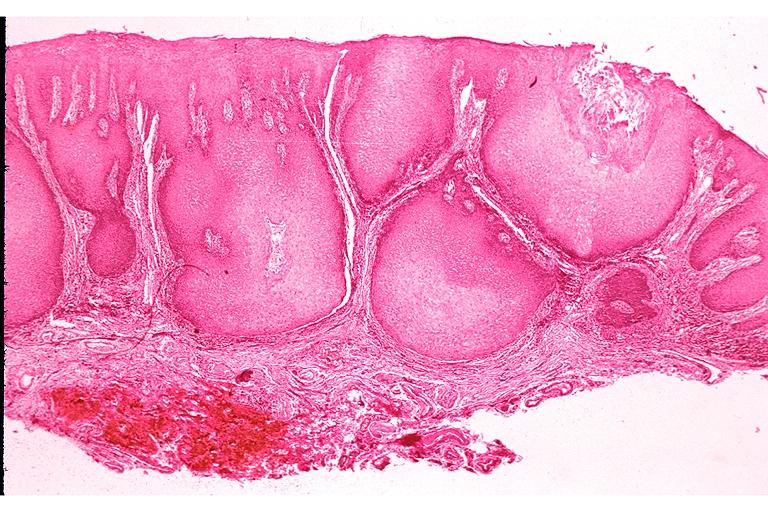where is this?
Answer the question using a single word or phrase. Oral 